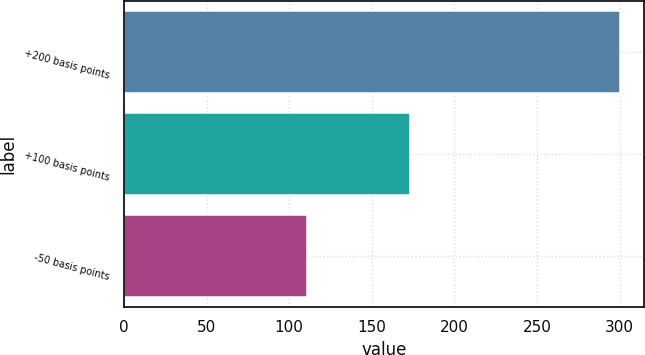Convert chart to OTSL. <chart><loc_0><loc_0><loc_500><loc_500><bar_chart><fcel>+200 basis points<fcel>+100 basis points<fcel>-50 basis points<nl><fcel>300<fcel>173<fcel>111<nl></chart> 